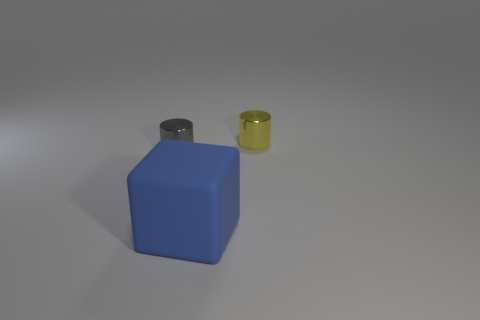Are there any other things that are the same size as the matte thing?
Ensure brevity in your answer.  No. Is there anything else that is the same material as the large cube?
Your answer should be very brief. No. Do the metallic cylinder to the left of the yellow thing and the yellow shiny object to the right of the big blue matte cube have the same size?
Your answer should be very brief. Yes. What number of objects are either blue objects or metal objects that are on the right side of the big matte block?
Offer a terse response. 2. Is there another object that has the same shape as the small gray metal thing?
Your answer should be very brief. Yes. There is a thing in front of the small object that is to the left of the yellow metal thing; how big is it?
Provide a succinct answer. Large. What number of matte objects are either tiny gray things or tiny yellow cylinders?
Your response must be concise. 0. How many small gray cylinders are there?
Ensure brevity in your answer.  1. Do the gray thing left of the big object and the object in front of the tiny gray metal thing have the same material?
Make the answer very short. No. What is the color of the other tiny metallic thing that is the same shape as the yellow metallic thing?
Offer a very short reply. Gray. 